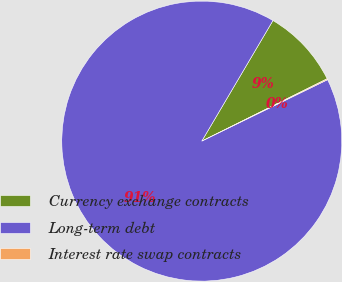<chart> <loc_0><loc_0><loc_500><loc_500><pie_chart><fcel>Currency exchange contracts<fcel>Long-term debt<fcel>Interest rate swap contracts<nl><fcel>9.17%<fcel>90.71%<fcel>0.11%<nl></chart> 